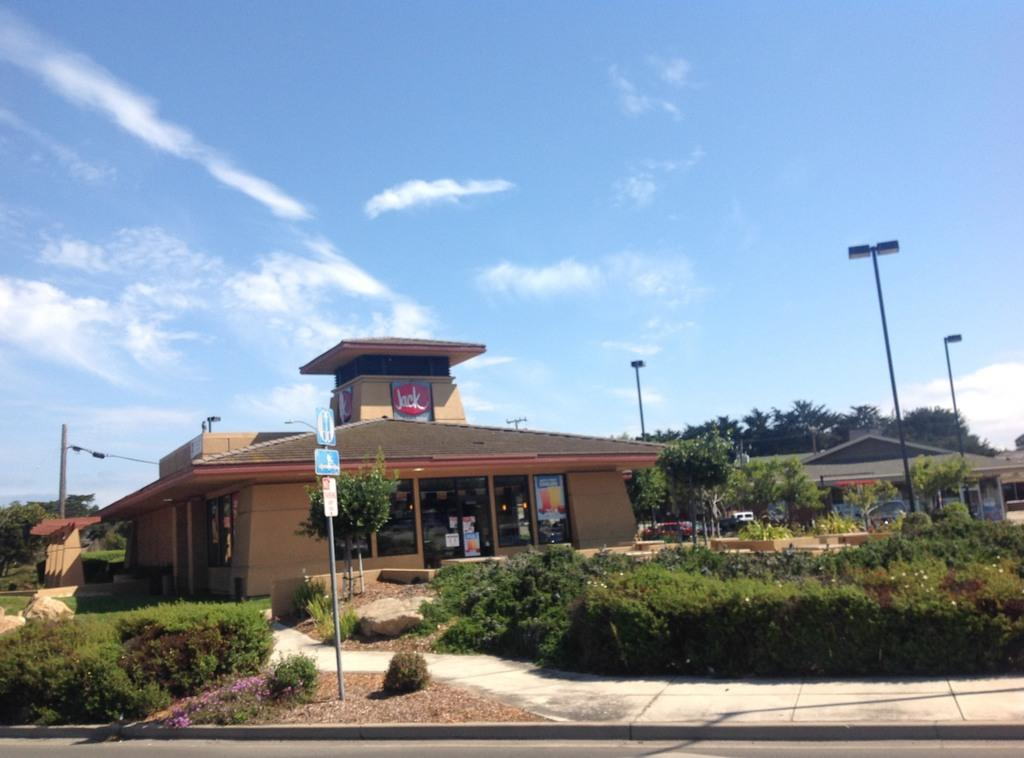What is the main subject of the image? The main subject of the image is a building. What can be seen in front of the building? There are trees and utility poles in front of the building. What is visible in the background of the image? The sky is visible in the background of the image. How many chairs are stacked on top of each other in the image? There are no chairs present in the image. 